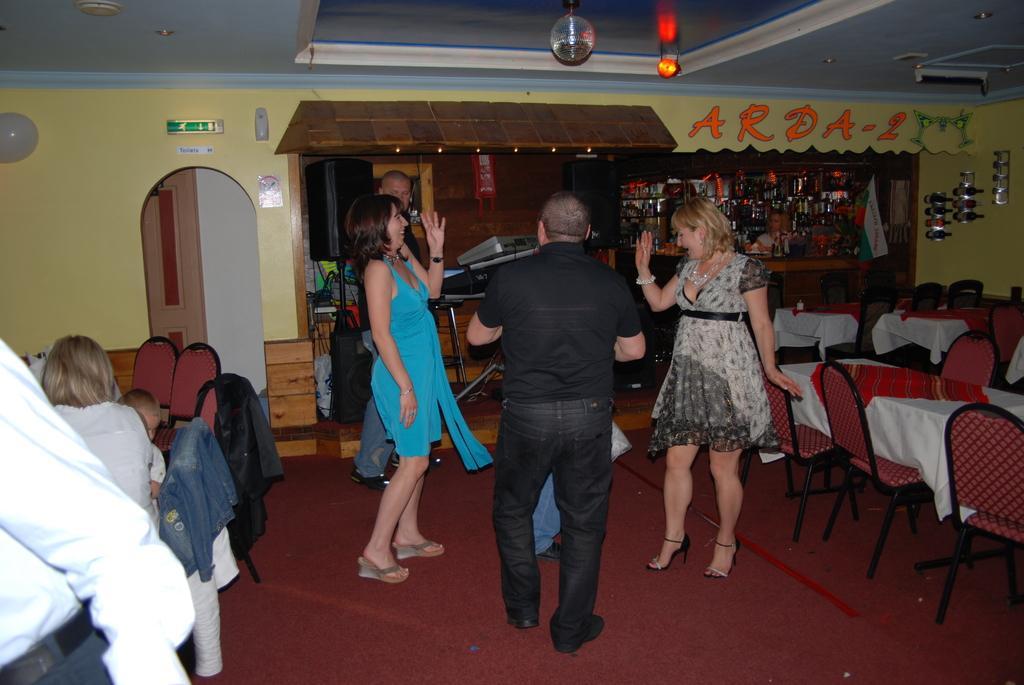Could you give a brief overview of what you see in this image? As we can see in the image there is a yellow color wall, mirror, few people sitting and standing on floor, tables and chairs. 